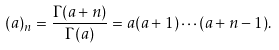<formula> <loc_0><loc_0><loc_500><loc_500>( a ) _ { n } = \frac { \Gamma ( a + n ) } { \Gamma ( a ) } = a ( a + 1 ) \cdots ( a + n - 1 ) .</formula> 